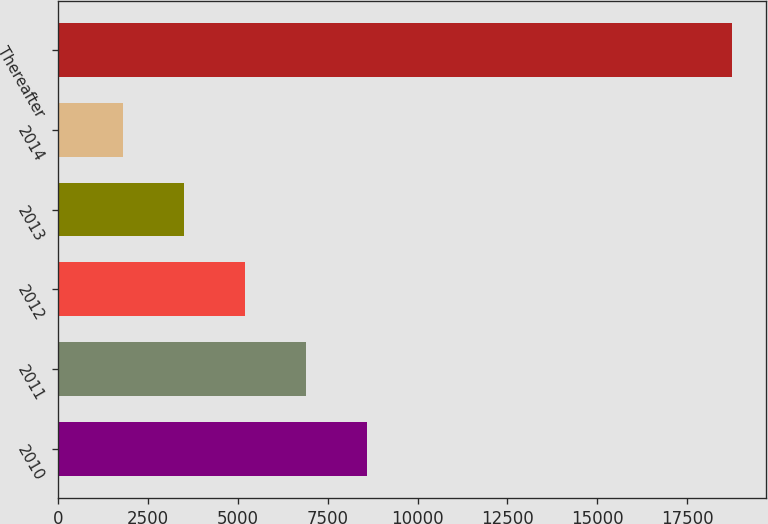Convert chart. <chart><loc_0><loc_0><loc_500><loc_500><bar_chart><fcel>2010<fcel>2011<fcel>2012<fcel>2013<fcel>2014<fcel>Thereafter<nl><fcel>8590.8<fcel>6895.6<fcel>5200.4<fcel>3505.2<fcel>1810<fcel>18762<nl></chart> 